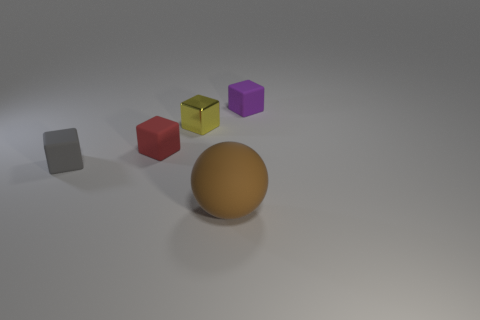Add 2 large objects. How many objects exist? 7 Subtract all spheres. How many objects are left? 4 Subtract all tiny red matte objects. Subtract all small red objects. How many objects are left? 3 Add 5 tiny yellow metallic cubes. How many tiny yellow metallic cubes are left? 6 Add 3 tiny objects. How many tiny objects exist? 7 Subtract 0 purple cylinders. How many objects are left? 5 